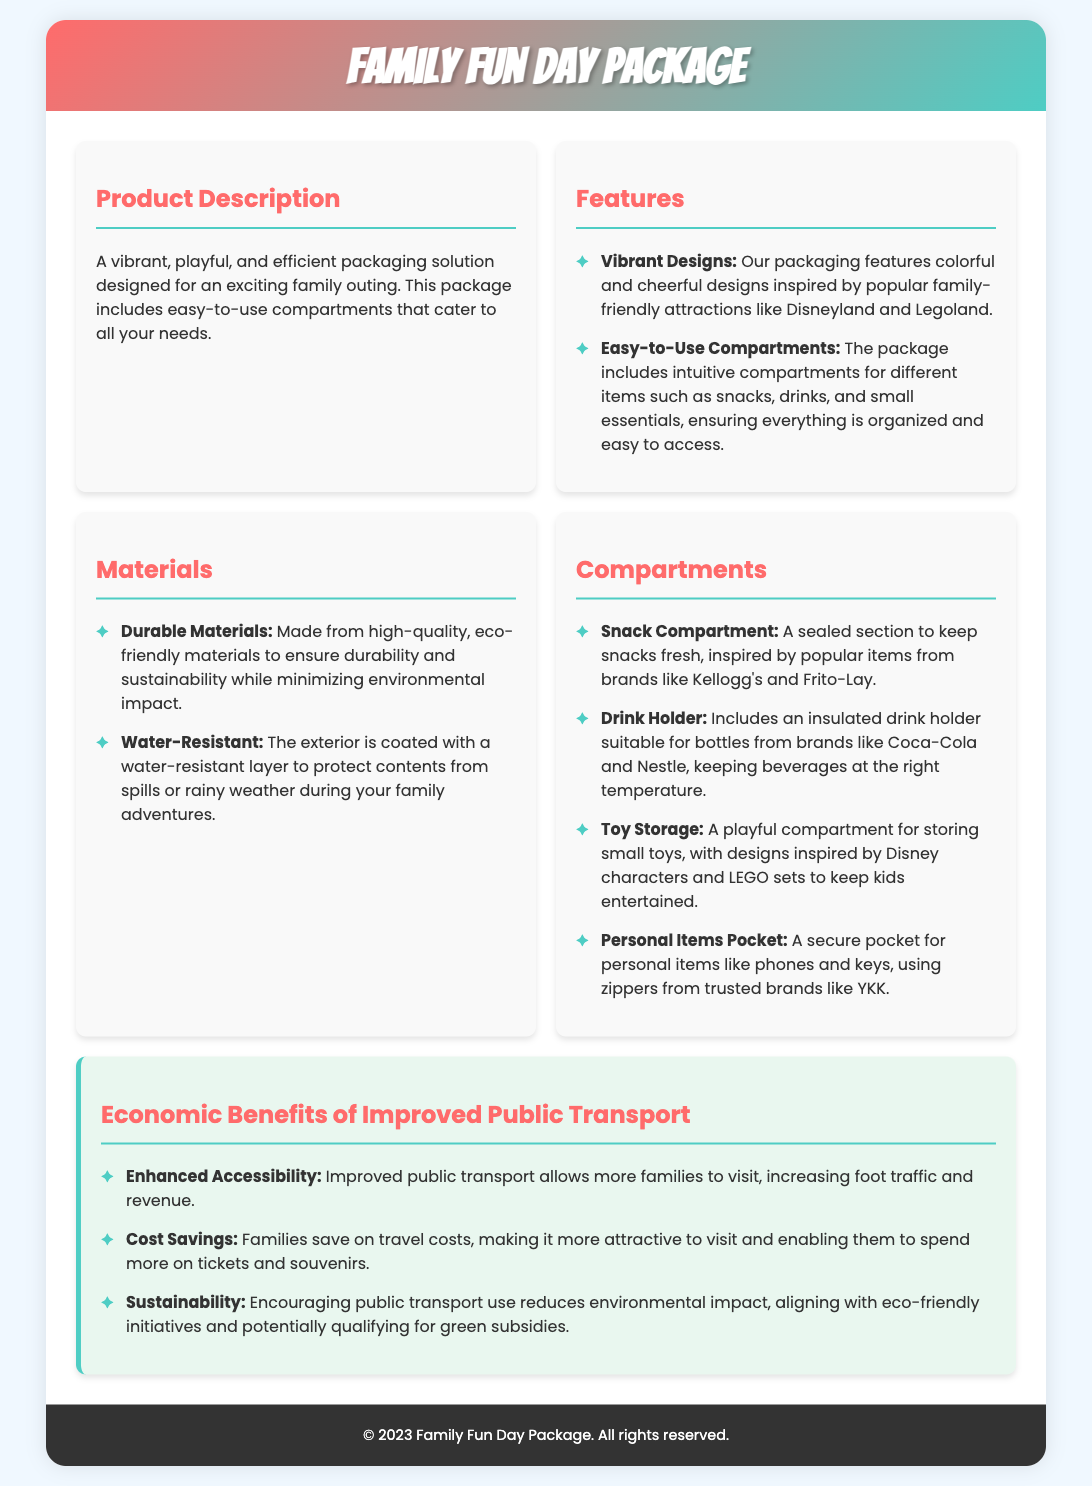What is the product's title? The title of the product, as stated in the document, is prominently displayed at the top.
Answer: Family Fun Day Package What type of designs does the packaging feature? The document describes the packaging's designs in the features section, indicating their characteristics.
Answer: Vibrant Designs What are the compartments intended for? There is a list of compartments included in the packaging, detailing their specific purposes.
Answer: Different items such as snacks, drinks, and small essentials Which materials are used for the packaging? The materials section outlines the types of materials utilized to create the product.
Answer: Durable Materials What is the benefit of improved public transport mentioned? The economic benefits section highlights several advantages related to public transport improvements.
Answer: Enhanced Accessibility How many types of compartments are mentioned? The compartments section provides a specific count of distinct areas designated for different items.
Answer: Four What organization's materials are referenced for durability? There is a mention of an organization that contributes to the product's material quality.
Answer: YKK What kind of impact does public transport improvement have on families? The document explains the effects of public transport enhancements on family visits and expenses savings.
Answer: Cost Savings What color scheme is used for the header? The document describes the color scheme that highlights the header's visual appeal.
Answer: Linear gradient of pink and teal 